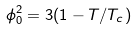Convert formula to latex. <formula><loc_0><loc_0><loc_500><loc_500>\phi _ { 0 } ^ { 2 } = 3 ( 1 - T / T _ { c } )</formula> 